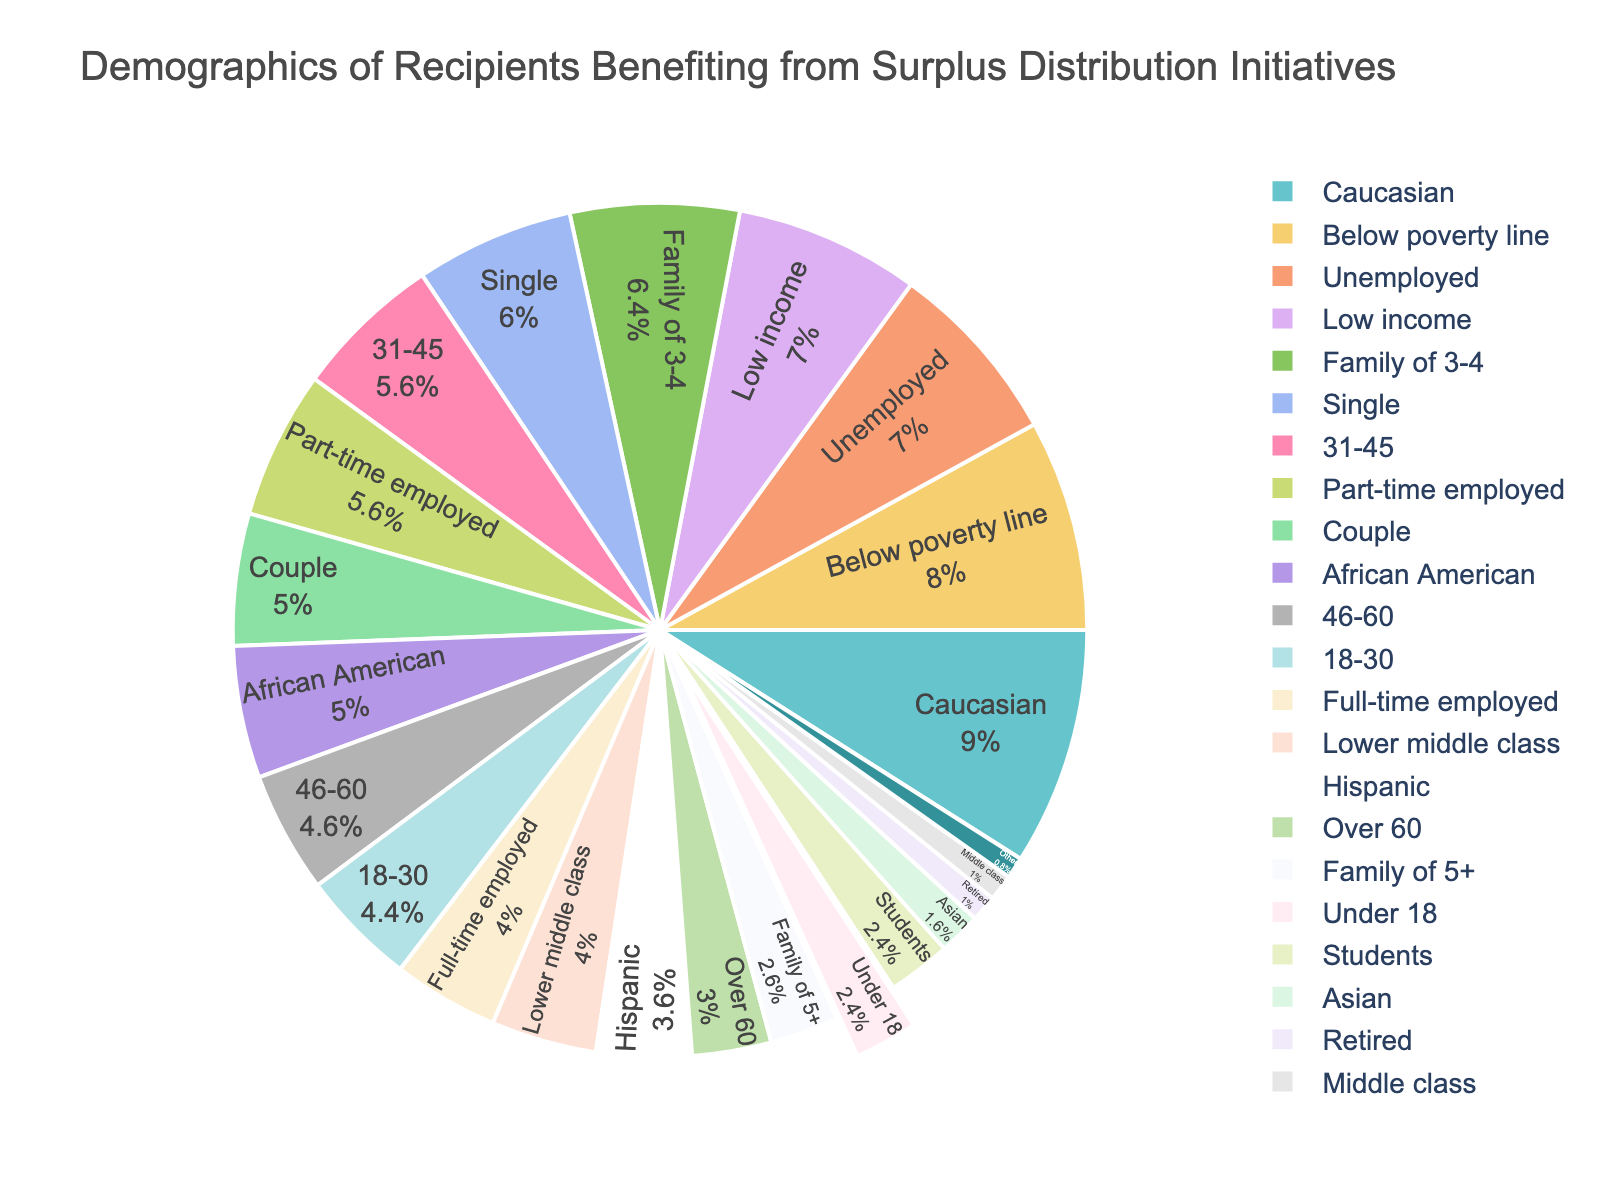What is the largest age group benefiting from the surplus distribution initiatives? The pie chart shows that the age group with the highest percentage is 31-45, with 28%.
Answer: 31-45 Which age group has a slightly smaller percentage compared to the 31-45 age group? By examining the pie chart, the 46-60 age group has a percentage of 23%, which is slightly smaller than the 31-45 age group's 28%.
Answer: 46-60 What is the combined percentage of the age groups 18-30 and 46-60? The percentage of the 18-30 age group is 22%, and the percentage of the 46-60 age group is 23%. Adding them together gives 22% + 23% = 45%.
Answer: 45% How much larger is the percentage of recipients aged 31-45 compared to those aged Over 60? The percentage for the 31-45 age group is 28%, and for the Over 60 age group, it is 15%. The difference is 28% - 15% = 13%.
Answer: 13% Which age group is represented with a pull-out segment in the pie chart? The visual attribute of the pie chart, which shows a segment slightly pulled out, belongs to the Under 18 age group.
Answer: Under 18 List the age groups in decreasing order of their percentage. From the pie chart, the age groups in decreasing order are 31-45 (28%), 46-60 (23%), 18-30 (22%), Over 60 (15%), and Under 18 (12%).
Answer: 31-45, 46-60, 18-30, Over 60, Under 18 What is the percentage difference between the age groups with the maximum and minimum percentages? The maximum percentage is in the 31-45 age group (28%) and the minimum in the Under 18 age group (12%). The difference is 28% - 12% = 16%.
Answer: 16% Can you determine if the combination of Under 18 and Over 60 age groups is greater than the 31-45 age group? Adding the percentages of Under 18 (12%) and Over 60 (15%) results in 12% + 15% = 27%, which is less than the 31-45 age group (28%).
Answer: No Which age groups together make up more than half of the total percentage? Summing up the largest proportions from the age group categories, 31-45 (28%) and 46-60 (23%) results in a combined percentage of 28% + 23% = 51%, which is more than half.
Answer: 31-45 and 46-60 